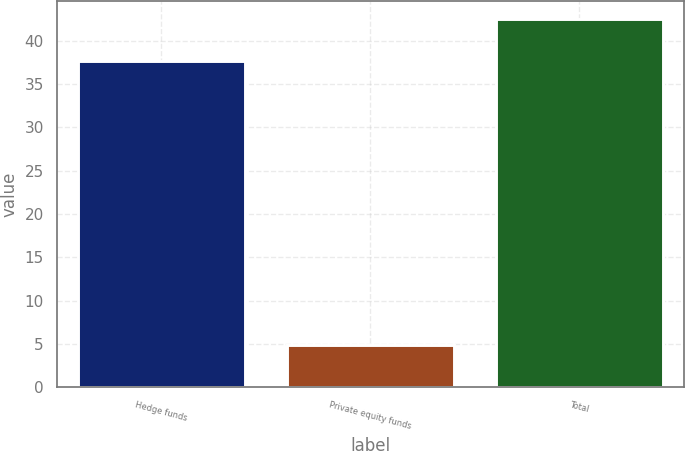Convert chart to OTSL. <chart><loc_0><loc_0><loc_500><loc_500><bar_chart><fcel>Hedge funds<fcel>Private equity funds<fcel>Total<nl><fcel>37.6<fcel>4.9<fcel>42.5<nl></chart> 